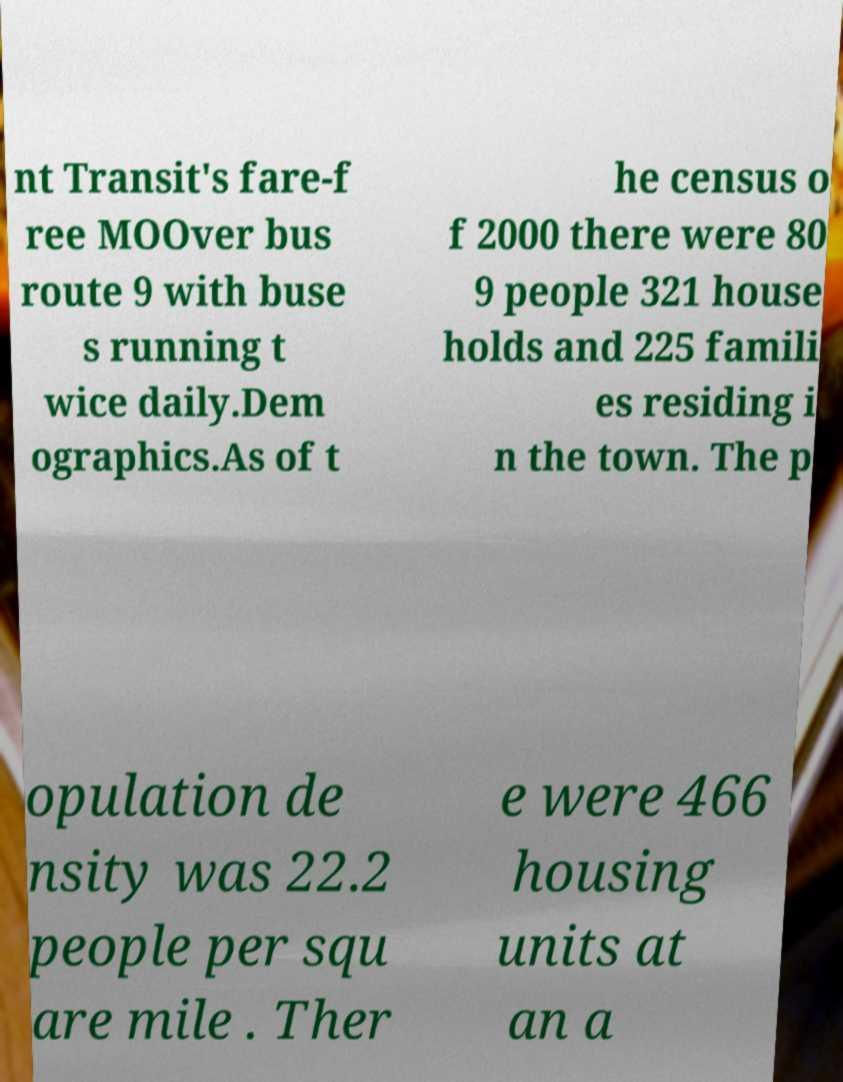Can you accurately transcribe the text from the provided image for me? nt Transit's fare-f ree MOOver bus route 9 with buse s running t wice daily.Dem ographics.As of t he census o f 2000 there were 80 9 people 321 house holds and 225 famili es residing i n the town. The p opulation de nsity was 22.2 people per squ are mile . Ther e were 466 housing units at an a 